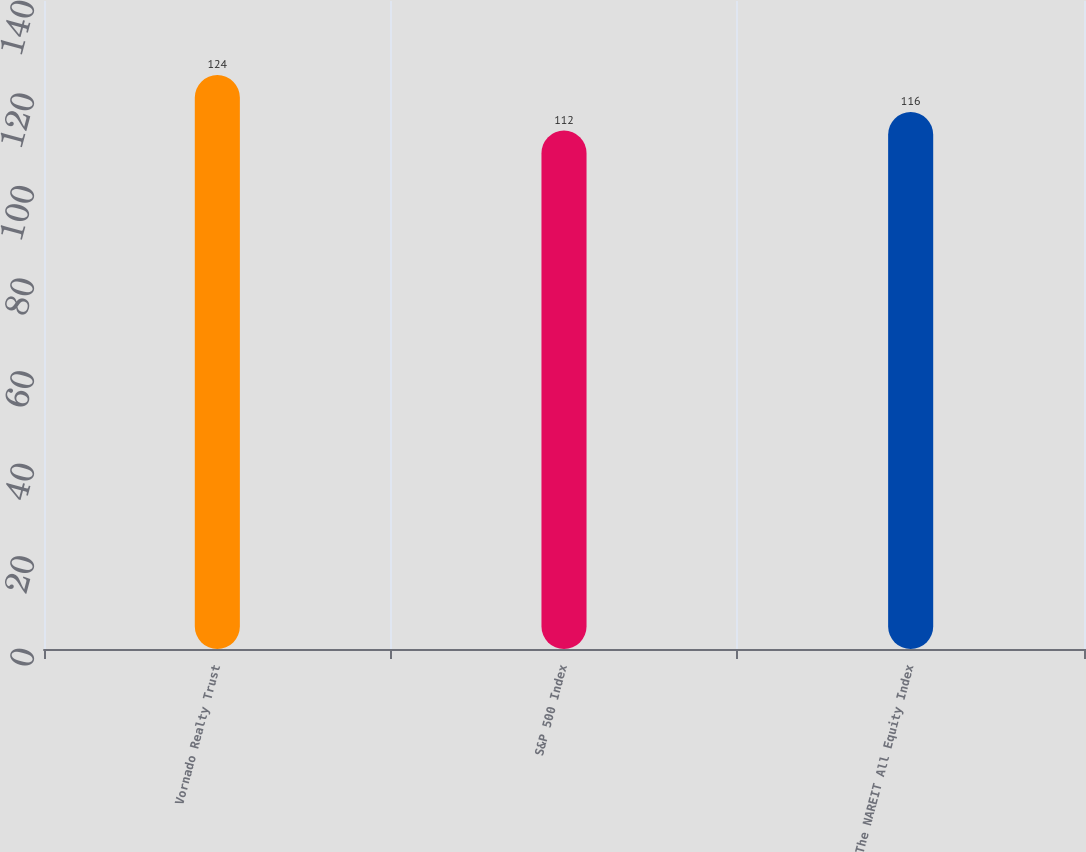Convert chart to OTSL. <chart><loc_0><loc_0><loc_500><loc_500><bar_chart><fcel>Vornado Realty Trust<fcel>S&P 500 Index<fcel>The NAREIT All Equity Index<nl><fcel>124<fcel>112<fcel>116<nl></chart> 